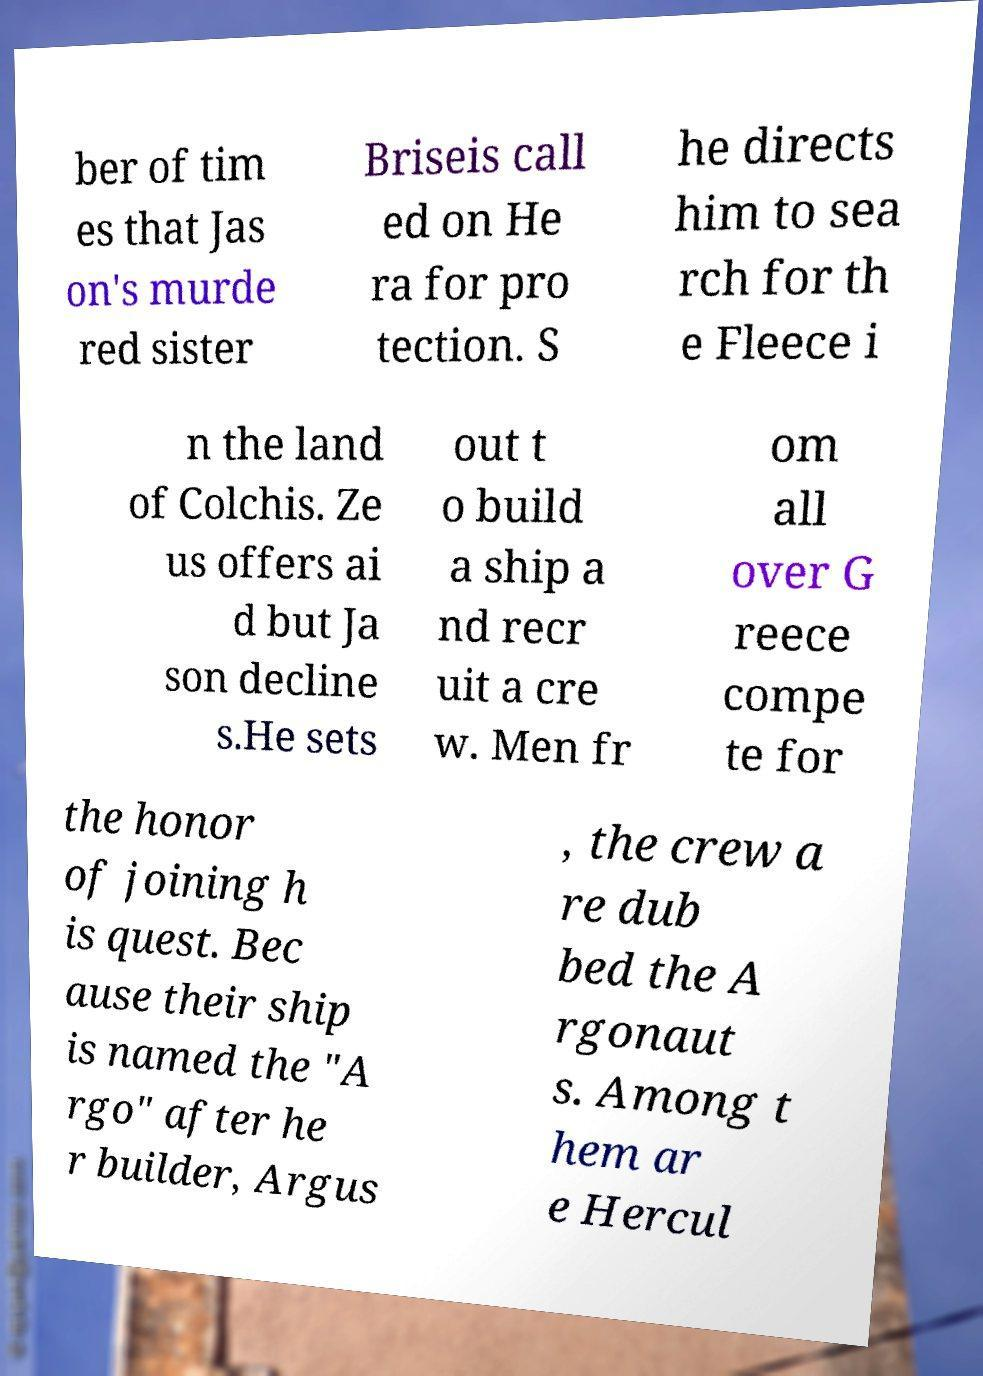What messages or text are displayed in this image? I need them in a readable, typed format. ber of tim es that Jas on's murde red sister Briseis call ed on He ra for pro tection. S he directs him to sea rch for th e Fleece i n the land of Colchis. Ze us offers ai d but Ja son decline s.He sets out t o build a ship a nd recr uit a cre w. Men fr om all over G reece compe te for the honor of joining h is quest. Bec ause their ship is named the "A rgo" after he r builder, Argus , the crew a re dub bed the A rgonaut s. Among t hem ar e Hercul 